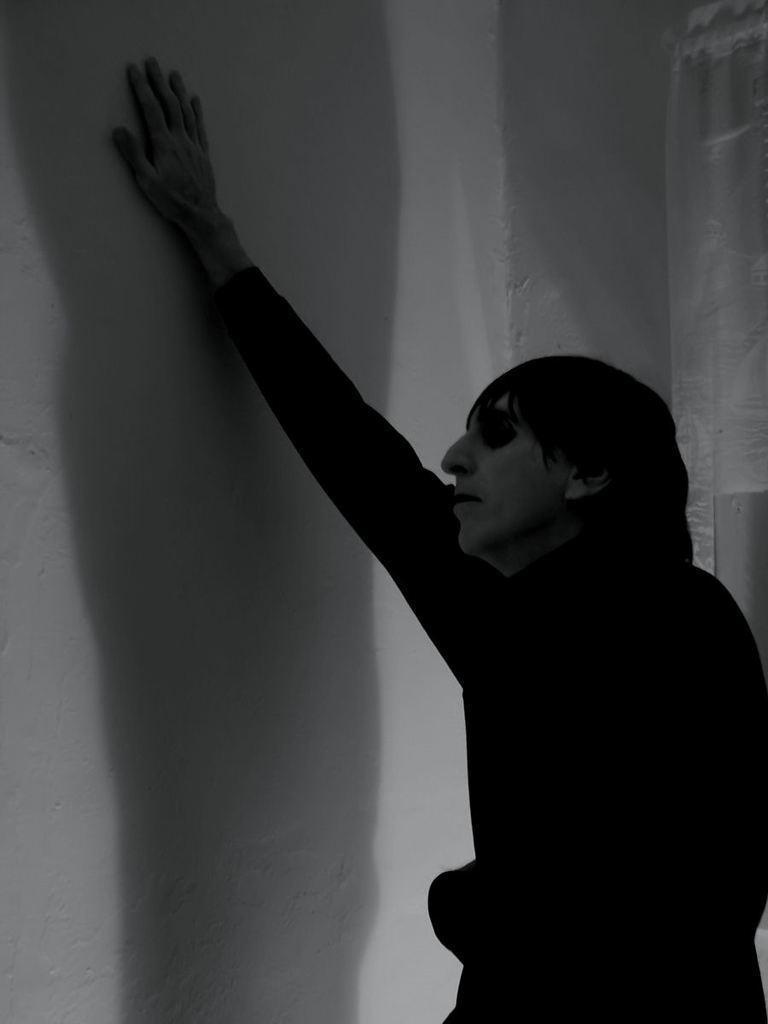Can you describe this image briefly? This picture shows a man standing and we see his hand on the wall. 